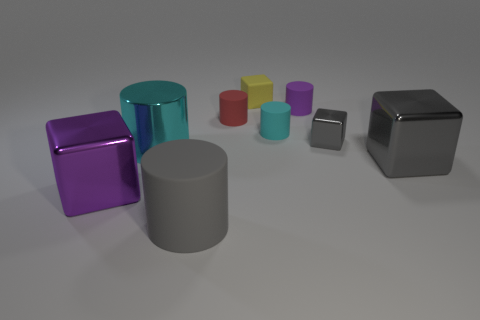Subtract all gray cylinders. How many cylinders are left? 4 Subtract all metal cylinders. How many cylinders are left? 4 Subtract all blue cylinders. Subtract all gray spheres. How many cylinders are left? 5 Add 1 small green matte objects. How many objects exist? 10 Subtract all cylinders. How many objects are left? 4 Add 2 purple things. How many purple things are left? 4 Add 6 tiny rubber cubes. How many tiny rubber cubes exist? 7 Subtract 1 gray cylinders. How many objects are left? 8 Subtract all gray matte objects. Subtract all small purple matte things. How many objects are left? 7 